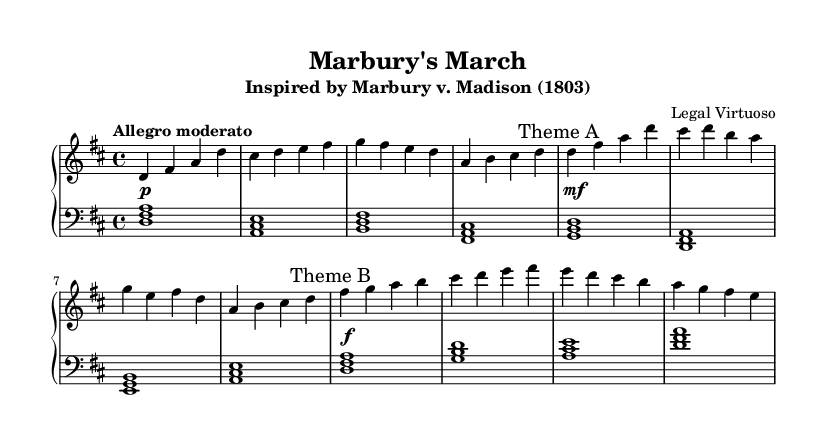What is the key signature of this music? The key signature is one sharp, indicating that the piece is in D major. You can find the key signature at the beginning of the staff, which shows one sharp.
Answer: D major What is the time signature of this composition? The time signature is indicated as 4/4, which means there are four beats in each measure and a quarter note receives one beat. You can see this notation at the start of the music.
Answer: 4/4 What tempo marking is used for this piece? The tempo marking "Allegro moderato" suggests that the music should be played at a moderately fast speed. This indication appears at the beginning of the score.
Answer: Allegro moderato Identify the first theme in this music. The first theme is marked as "Theme A" and consists of a specific melody repeated in the right hand. It can be identified by looking for the marking within the music notation that clearly indicates it.
Answer: Theme A What is the total number of measures in the right hand's part? By counting the measures comprising the right hand part, there are a total of eight measures in the right hand arrangement of this piece. Each segment has been visually divided for clarity.
Answer: Eight measures Describe the chord progression in the left hand. The left hand's chord progression follows a sequence starting with D major, then moves to A major, progresses to B minor, and concludes with F sharp minor. You can identify the chords by looking at the note clusters formed in the left hand staff.
Answer: D, A, B, F sharp 